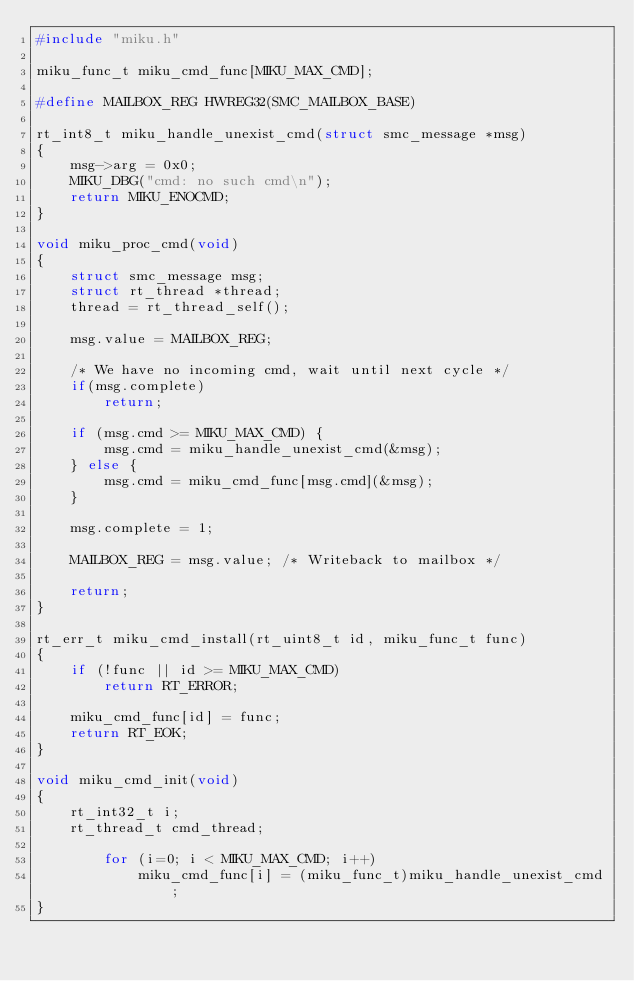Convert code to text. <code><loc_0><loc_0><loc_500><loc_500><_C_>#include "miku.h"

miku_func_t miku_cmd_func[MIKU_MAX_CMD];

#define MAILBOX_REG	HWREG32(SMC_MAILBOX_BASE)

rt_int8_t miku_handle_unexist_cmd(struct smc_message *msg)
{
	msg->arg = 0x0;
	MIKU_DBG("cmd: no such cmd\n");
	return MIKU_ENOCMD;
}

void miku_proc_cmd(void)
{
	struct smc_message msg;
	struct rt_thread *thread;
	thread = rt_thread_self();

	msg.value = MAILBOX_REG;

	/* We have no incoming cmd, wait until next cycle */
	if(msg.complete)
		return;

	if (msg.cmd >= MIKU_MAX_CMD) {
		msg.cmd = miku_handle_unexist_cmd(&msg);
	} else {
		msg.cmd = miku_cmd_func[msg.cmd](&msg);
	}

	msg.complete = 1;

	MAILBOX_REG = msg.value; /* Writeback to mailbox */

	return;
}

rt_err_t miku_cmd_install(rt_uint8_t id, miku_func_t func)
{
	if (!func || id >= MIKU_MAX_CMD)
		return RT_ERROR;
	
	miku_cmd_func[id] = func;
	return RT_EOK;
}

void miku_cmd_init(void)
{
	rt_int32_t i;
	rt_thread_t cmd_thread;

    	for (i=0; i < MIKU_MAX_CMD; i++)
        	miku_cmd_func[i] = (miku_func_t)miku_handle_unexist_cmd;
}</code> 